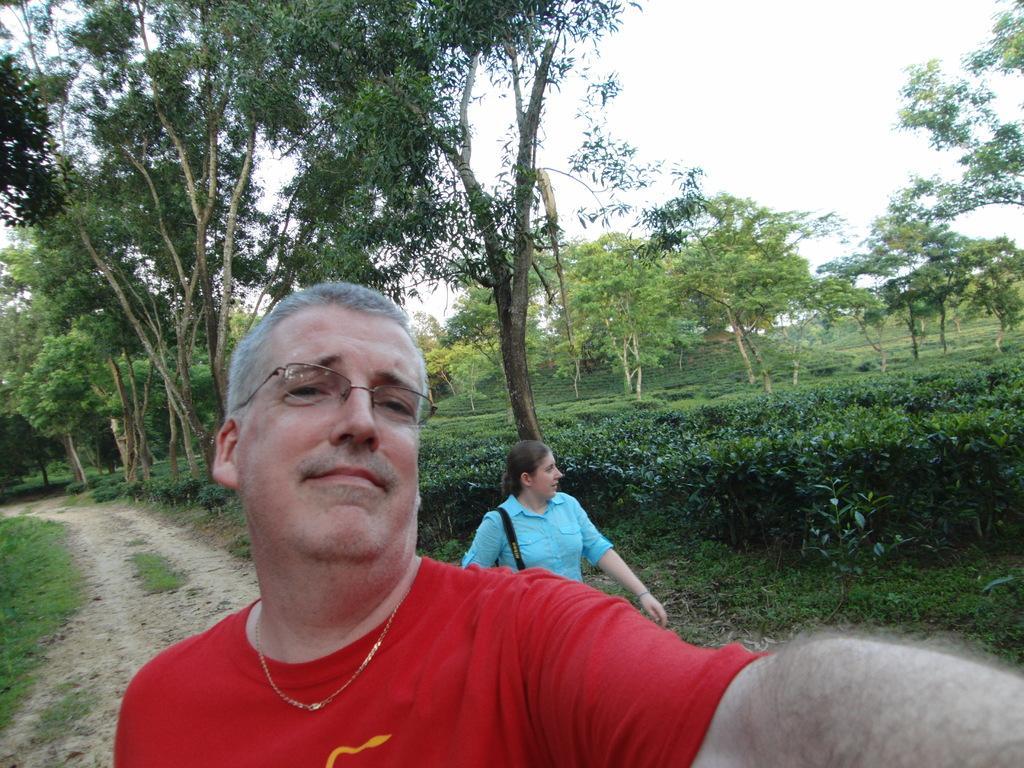Describe this image in one or two sentences. In the center of the image there is a person wearing red color t-shirt. Behind him there is a lady wearing a blue color shirt. In the background of the image there are trees. 